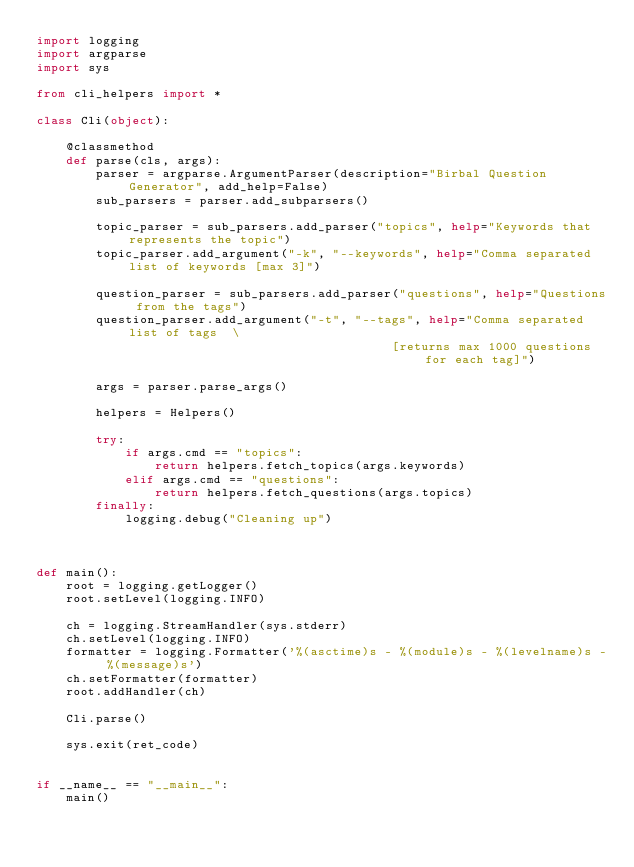<code> <loc_0><loc_0><loc_500><loc_500><_Python_>import logging
import argparse
import sys

from cli_helpers import *

class Cli(object):

    @classmethod
    def parse(cls, args):
        parser = argparse.ArgumentParser(description="Birbal Question Generator", add_help=False)
        sub_parsers = parser.add_subparsers()

        topic_parser = sub_parsers.add_parser("topics", help="Keywords that represents the topic")
        topic_parser.add_argument("-k", "--keywords", help="Comma separated list of keywords [max 3]")

        question_parser = sub_parsers.add_parser("questions", help="Questions from the tags")
        question_parser.add_argument("-t", "--tags", help="Comma separated list of tags  \
                                                [returns max 1000 questions for each tag]")

        args = parser.parse_args()

        helpers = Helpers()

        try:
            if args.cmd == "topics":
                return helpers.fetch_topics(args.keywords)
            elif args.cmd == "questions":
                return helpers.fetch_questions(args.topics)
        finally:
            logging.debug("Cleaning up")



def main():
    root = logging.getLogger()
    root.setLevel(logging.INFO)

    ch = logging.StreamHandler(sys.stderr)
    ch.setLevel(logging.INFO)
    formatter = logging.Formatter('%(asctime)s - %(module)s - %(levelname)s - %(message)s')
    ch.setFormatter(formatter)
    root.addHandler(ch)

    Cli.parse()

    sys.exit(ret_code)


if __name__ == "__main__":
    main()</code> 